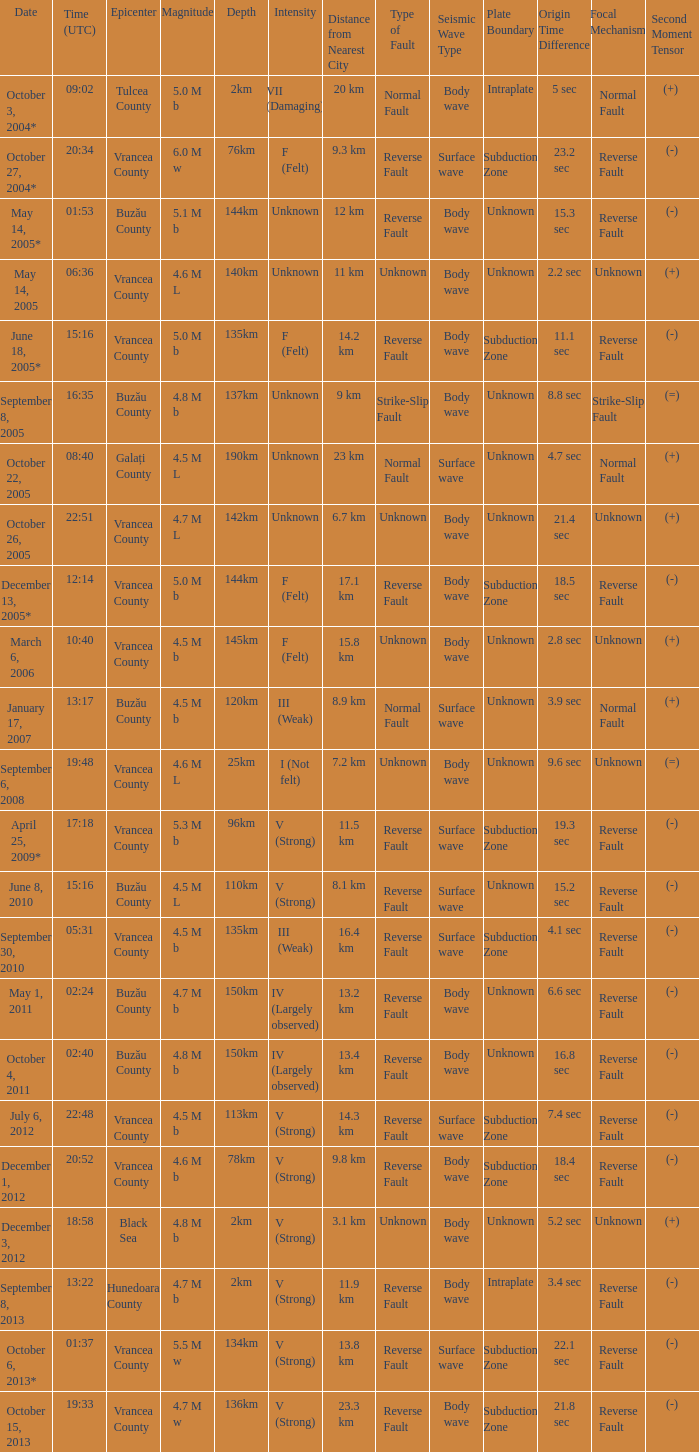What is the depth of the quake that occurred at 19:48? 25km. 